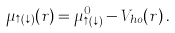<formula> <loc_0><loc_0><loc_500><loc_500>\mu _ { \uparrow ( \downarrow ) } ( { r } ) = \mu ^ { 0 } _ { \uparrow ( \downarrow ) } - V _ { h o } ( { r } ) \, .</formula> 